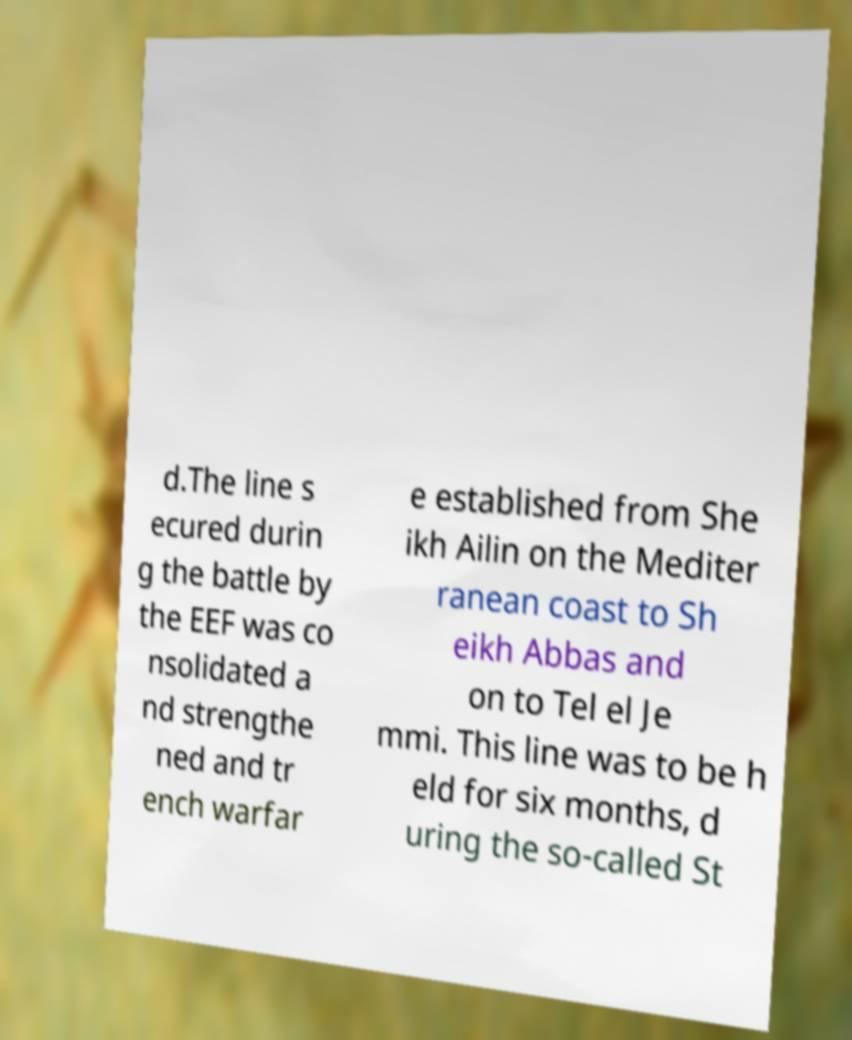Can you accurately transcribe the text from the provided image for me? d.The line s ecured durin g the battle by the EEF was co nsolidated a nd strengthe ned and tr ench warfar e established from She ikh Ailin on the Mediter ranean coast to Sh eikh Abbas and on to Tel el Je mmi. This line was to be h eld for six months, d uring the so-called St 